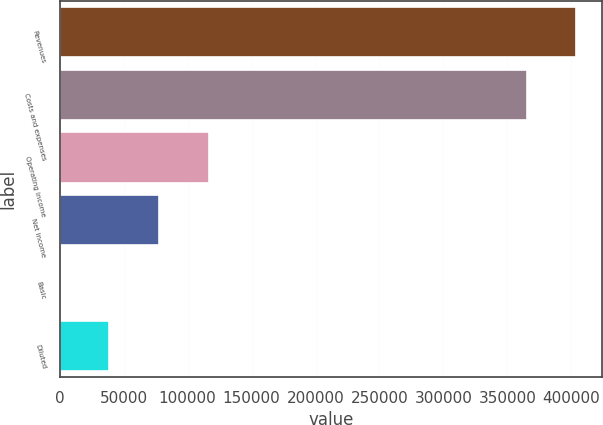Convert chart to OTSL. <chart><loc_0><loc_0><loc_500><loc_500><bar_chart><fcel>Revenues<fcel>Costs and expenses<fcel>Operating income<fcel>Net income<fcel>Basic<fcel>Diluted<nl><fcel>403841<fcel>364928<fcel>116738<fcel>77825.7<fcel>0.08<fcel>38912.9<nl></chart> 